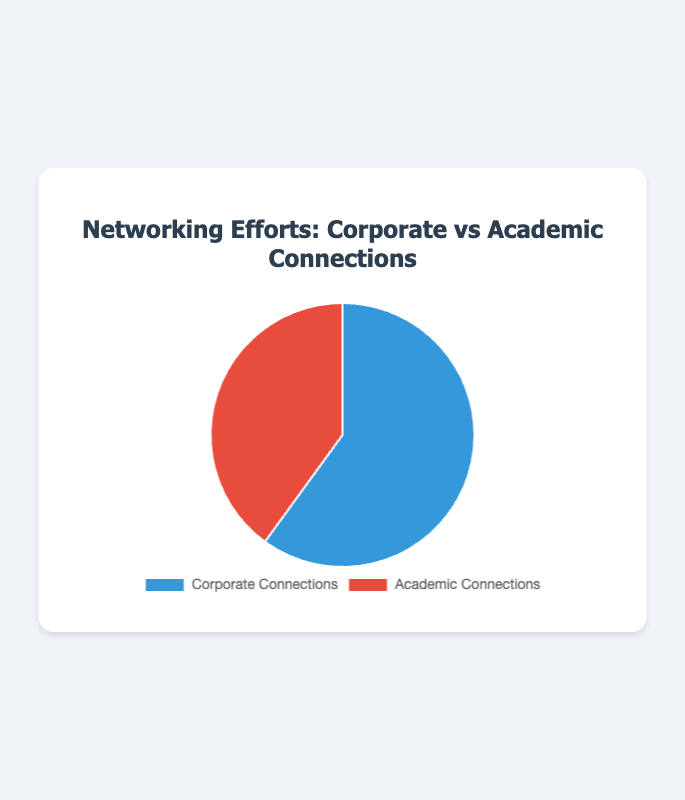What is the total number of hours spent on networking efforts? The total number of hours is the sum of the hours spent on corporate connections and academic connections. Therefore, it is 120 hours (Corporate Connections) + 80 hours (Academic Connections) = 200 hours.
Answer: 200 hours Which connection type has more time spent on it? To determine this, compare the hours spent on Corporate Connections (120 hours) and Academic Connections (80 hours). Corporate Connections has more time spent on it.
Answer: Corporate Connections What percentage of the total networking effort is spent on academic connections? First, find the total hours spent on networking efforts, which is 200 hours. Then, divide the hours spent on academic connections (80 hours) by the total hours and convert it to a percentage: (80/200) × 100% = 40%.
Answer: 40% Which section of the pie chart is colored blue? The blue section represents Corporate Connections. According to the color coding provided, Corporate Connections are marked with blue.
Answer: Corporate Connections How much more time is spent on corporate connections compared to academic connections? The difference between the time spent on Corporate Connections and Academic Connections is 120 hours - 80 hours = 40 hours.
Answer: 40 hours What portion of the pie chart is larger? By comparing the two sections, the section representing Corporate Connections is larger as it represents 120 hours out of the total 200 hours, which is greater than the 80 hours spent on Academic Connections.
Answer: Corporate Connections How many times is the time spent on corporate connections relative to academic connections? To find this, divide the time spent on Corporate Connections by the time spent on Academic Connections: 120 hours / 80 hours = 1.5. So, the time spent on Corporate Connections is 1.5 times that of Academic Connections.
Answer: 1.5 times What is the difference in percentage points between time spent on corporate connections and academic connections? First, find the percentage of time spent on each: Corporate Connections: (120/200) × 100% = 60%, Academic Connections: (80/200) × 100% = 40%. The difference is 60% - 40% = 20 percentage points.
Answer: 20 percentage points What colors are used in the pie chart for networking efforts? The pie chart uses two colors: blue for Corporate Connections and red for Academic Connections.
Answer: Blue and Red If 20 more hours were added to academic connections, which connection type would then have more time spent? If 20 more hours are added to the 80 hours for Academic Connections, it becomes 100 hours. Corporate Connections have 120 hours. Even with an additional 20 hours, Corporate Connections would still have more time spent as 120 is still greater than 100.
Answer: Corporate Connections 